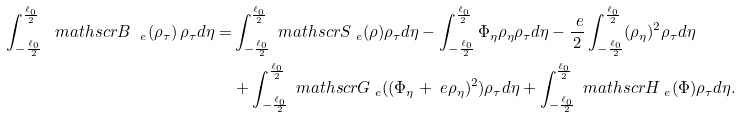<formula> <loc_0><loc_0><loc_500><loc_500>\int _ { - \frac { \ell _ { 0 } } { 2 } } ^ { \frac { \ell _ { 0 } } { 2 } } { \ m a t h s c r B } _ { \ e } ( \rho _ { \tau } ) \, \rho _ { \tau } d \eta = & \int _ { - \frac { \ell _ { 0 } } { 2 } } ^ { \frac { \ell _ { 0 } } { 2 } } { \ m a t h s c r S } _ { \ e } ( \rho ) \rho _ { \tau } d \eta - \int _ { - \frac { \ell _ { 0 } } { 2 } } ^ { \frac { \ell _ { 0 } } { 2 } } \Phi _ { \eta } \rho _ { \eta } \rho _ { \tau } d \eta - \frac { \ e } { 2 } \int _ { - \frac { \ell _ { 0 } } { 2 } } ^ { \frac { \ell _ { 0 } } { 2 } } ( \rho _ { \eta } ) ^ { 2 } \rho _ { \tau } d \eta \\ & + \int _ { - \frac { \ell _ { 0 } } { 2 } } ^ { \frac { \ell _ { 0 } } { 2 } } { \ m a t h s c r G } _ { \ e } ( ( \Phi _ { \eta } + \ e \rho _ { \eta } ) ^ { 2 } ) \rho _ { \tau } d \eta + \int _ { - \frac { \ell _ { 0 } } { 2 } } ^ { \frac { \ell _ { 0 } } { 2 } } { \ m a t h s c r H } _ { \ e } ( \Phi ) \rho _ { \tau } d \eta .</formula> 